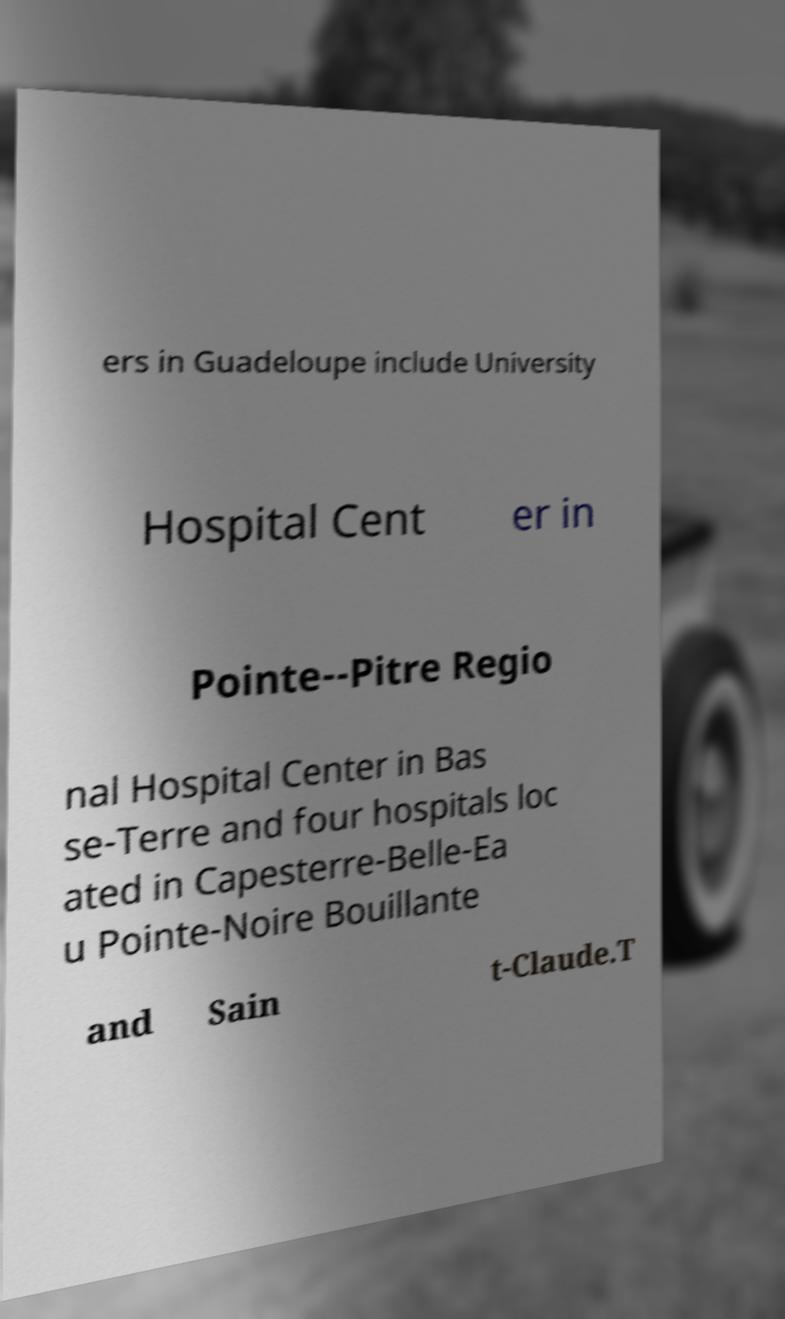I need the written content from this picture converted into text. Can you do that? ers in Guadeloupe include University Hospital Cent er in Pointe--Pitre Regio nal Hospital Center in Bas se-Terre and four hospitals loc ated in Capesterre-Belle-Ea u Pointe-Noire Bouillante and Sain t-Claude.T 